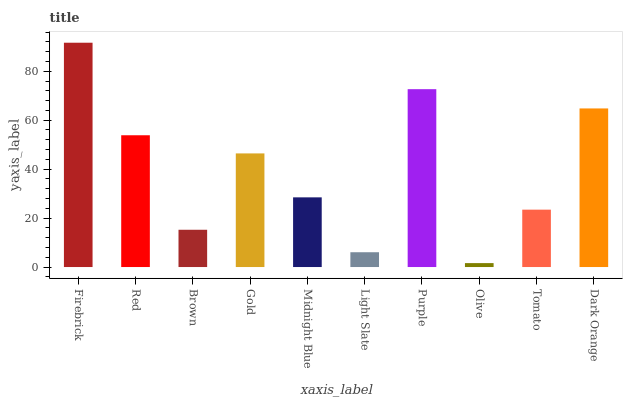Is Olive the minimum?
Answer yes or no. Yes. Is Firebrick the maximum?
Answer yes or no. Yes. Is Red the minimum?
Answer yes or no. No. Is Red the maximum?
Answer yes or no. No. Is Firebrick greater than Red?
Answer yes or no. Yes. Is Red less than Firebrick?
Answer yes or no. Yes. Is Red greater than Firebrick?
Answer yes or no. No. Is Firebrick less than Red?
Answer yes or no. No. Is Gold the high median?
Answer yes or no. Yes. Is Midnight Blue the low median?
Answer yes or no. Yes. Is Midnight Blue the high median?
Answer yes or no. No. Is Tomato the low median?
Answer yes or no. No. 